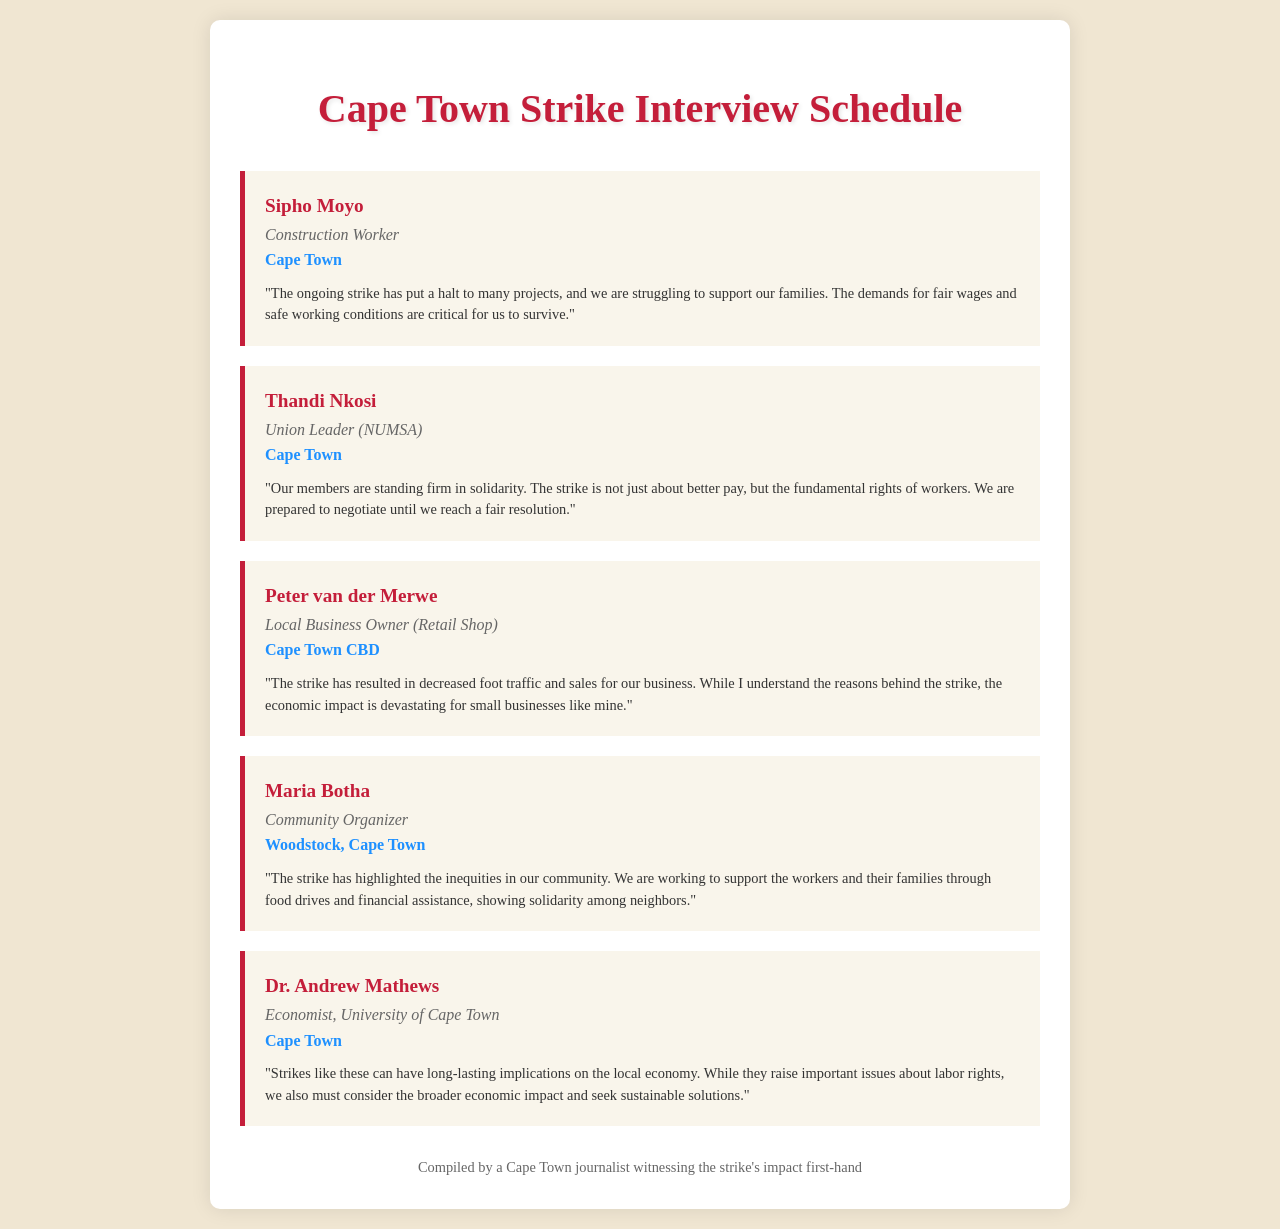What is the name of the construction worker interviewed? The name of the construction worker interviewed is mentioned as Sipho Moyo.
Answer: Sipho Moyo Which union is Thandi Nkosi associated with? Thandi Nkosi is associated with NUMSA, as stated in her role description.
Answer: NUMSA What is the primary concern expressed by Sipho Moyo? Sipho Moyo's primary concern revolves around fair wages and safe working conditions for workers.
Answer: fair wages and safe working conditions Where is Peter van der Merwe's business located? Peter van der Merwe's business is located in the Cape Town CBD, according to his location.
Answer: Cape Town CBD What type of support is Maria Botha providing to workers? Maria Botha mentions supporting workers through food drives and financial assistance, highlighting community solidarity.
Answer: food drives and financial assistance According to Dr. Andrew Mathews, what should be considered along with labor rights? Dr. Andrew Mathews emphasizes the need to consider the broader economic impact when discussing labor rights issues.
Answer: broader economic impact What is the occupation of Maria Botha? Maria Botha's occupation is identified as a Community Organizer in the document.
Answer: Community Organizer How does Peter van der Merwe describe the impact of the strike on his business? Peter van der Merwe describes the impact of the strike on his business as resulting in decreased foot traffic and sales.
Answer: decreased foot traffic and sales What is the overall theme of the interviews in the document? The overall theme of the interviews highlights the impact of the strike on various stakeholders, including workers, union leaders, and business owners.
Answer: impact of the strike 